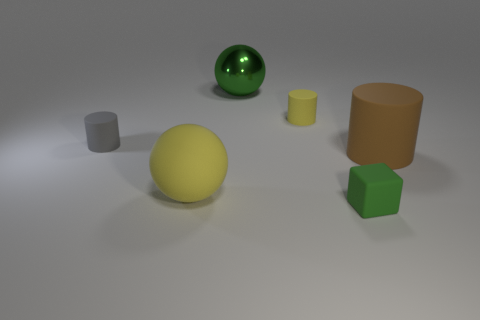What shape is the matte object that is the same color as the matte ball?
Offer a terse response. Cylinder. There is a yellow object that is the same shape as the big green thing; what material is it?
Your answer should be compact. Rubber. There is a large sphere that is behind the large yellow matte thing; does it have the same color as the tiny thing in front of the brown matte cylinder?
Make the answer very short. Yes. There is a ball to the right of the large ball in front of the small rubber cylinder that is left of the tiny yellow rubber cylinder; what size is it?
Your response must be concise. Large. What shape is the matte object that is to the left of the small yellow rubber object and behind the big brown thing?
Offer a terse response. Cylinder. Are there the same number of things that are left of the small green matte object and objects that are in front of the small yellow cylinder?
Provide a short and direct response. Yes. Is there a cube that has the same material as the yellow ball?
Your response must be concise. Yes. Is the sphere that is to the left of the big green object made of the same material as the large green ball?
Your answer should be very brief. No. How big is the rubber thing that is both on the right side of the big yellow matte object and on the left side of the cube?
Keep it short and to the point. Small. What is the color of the tiny matte block?
Give a very brief answer. Green. 